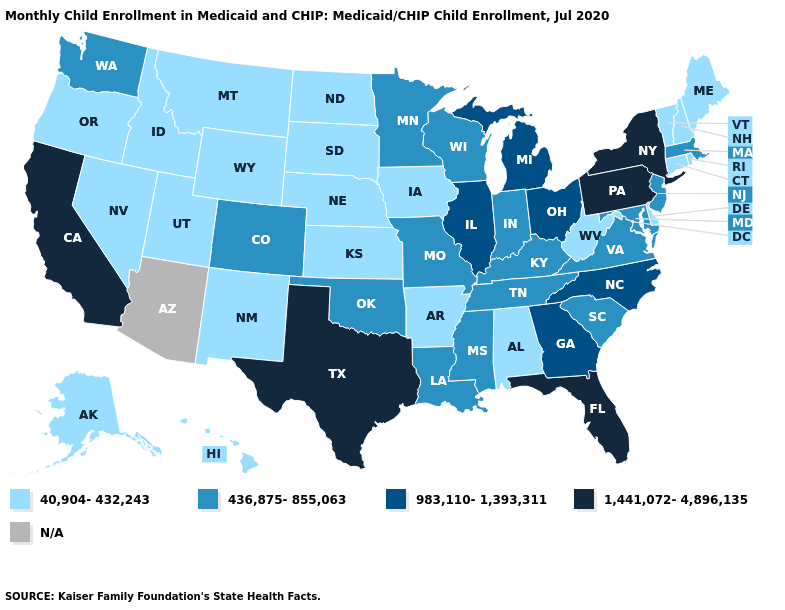Does Pennsylvania have the highest value in the Northeast?
Short answer required. Yes. What is the value of Nevada?
Quick response, please. 40,904-432,243. What is the value of Michigan?
Be succinct. 983,110-1,393,311. What is the value of Maine?
Give a very brief answer. 40,904-432,243. What is the value of Ohio?
Write a very short answer. 983,110-1,393,311. Does Florida have the highest value in the South?
Keep it brief. Yes. Does the map have missing data?
Be succinct. Yes. How many symbols are there in the legend?
Quick response, please. 5. Does Oklahoma have the highest value in the South?
Short answer required. No. Among the states that border Arizona , which have the lowest value?
Short answer required. Nevada, New Mexico, Utah. What is the value of Maryland?
Quick response, please. 436,875-855,063. Name the states that have a value in the range N/A?
Be succinct. Arizona. Name the states that have a value in the range 436,875-855,063?
Keep it brief. Colorado, Indiana, Kentucky, Louisiana, Maryland, Massachusetts, Minnesota, Mississippi, Missouri, New Jersey, Oklahoma, South Carolina, Tennessee, Virginia, Washington, Wisconsin. What is the lowest value in the USA?
Short answer required. 40,904-432,243. 